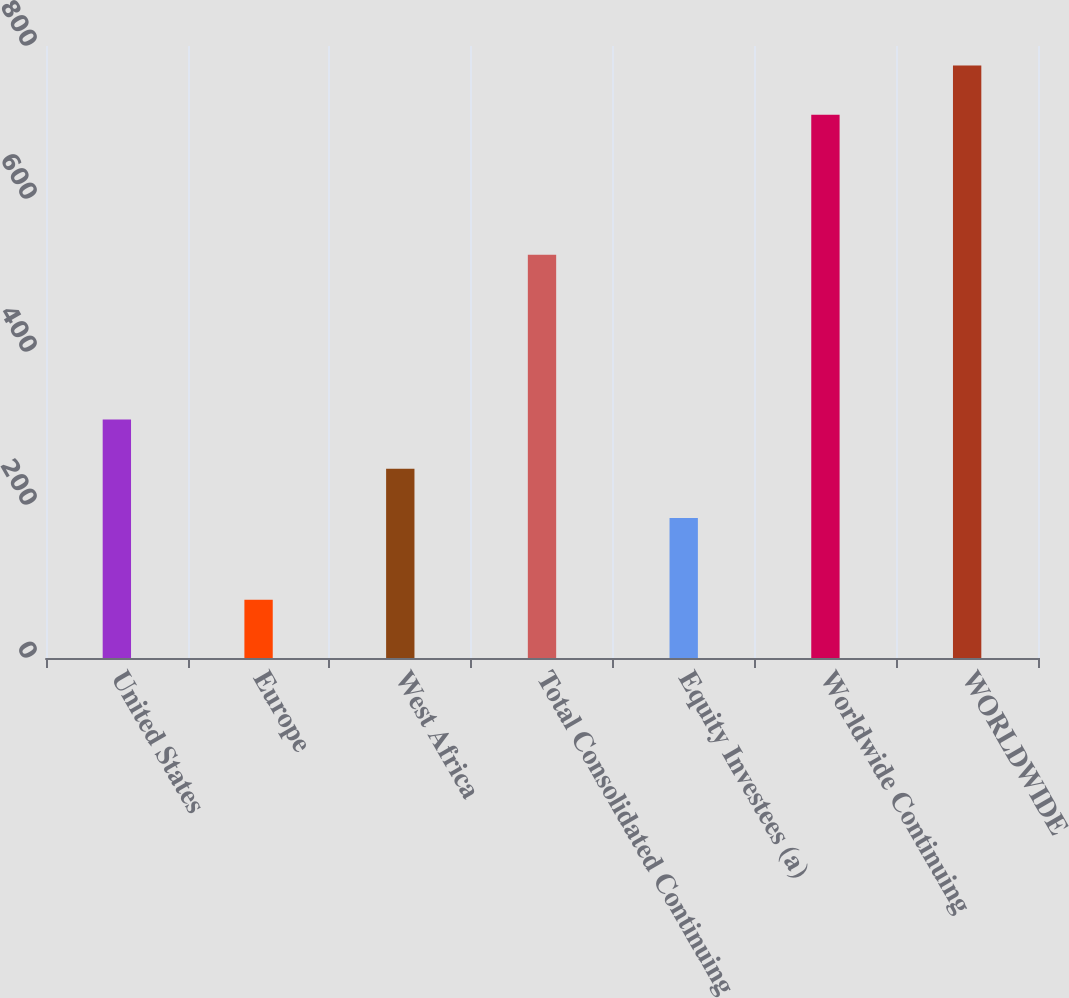Convert chart to OTSL. <chart><loc_0><loc_0><loc_500><loc_500><bar_chart><fcel>United States<fcel>Europe<fcel>West Africa<fcel>Total Consolidated Continuing<fcel>Equity Investees (a)<fcel>Worldwide Continuing<fcel>WORLDWIDE<nl><fcel>311.8<fcel>76<fcel>247.4<fcel>527<fcel>183<fcel>710<fcel>774.4<nl></chart> 